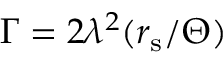Convert formula to latex. <formula><loc_0><loc_0><loc_500><loc_500>\Gamma = 2 \lambda ^ { 2 } ( r _ { s } / \Theta )</formula> 